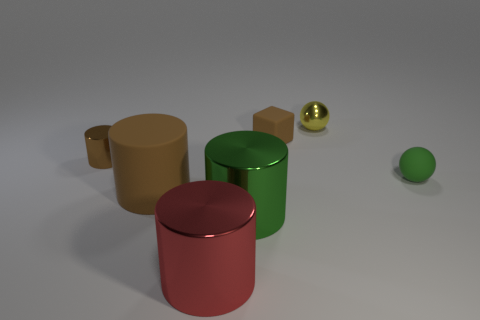Is there any other thing of the same color as the tiny cylinder?
Provide a succinct answer. Yes. There is a red object that is made of the same material as the green cylinder; what shape is it?
Make the answer very short. Cylinder. There is a ball that is in front of the brown object behind the small brown cylinder; how many rubber things are behind it?
Offer a terse response. 1. There is a thing that is both behind the green sphere and on the left side of the red cylinder; what is its shape?
Ensure brevity in your answer.  Cylinder. Are there fewer red objects behind the small brown matte block than tiny gray metal objects?
Provide a short and direct response. No. What number of tiny objects are red cylinders or spheres?
Your response must be concise. 2. What is the size of the red metal cylinder?
Keep it short and to the point. Large. There is a small brown matte cube; how many metallic objects are on the right side of it?
Your answer should be compact. 1. What size is the matte object that is the same shape as the brown shiny thing?
Keep it short and to the point. Large. There is a thing that is both in front of the small metallic ball and behind the small brown cylinder; what size is it?
Make the answer very short. Small. 